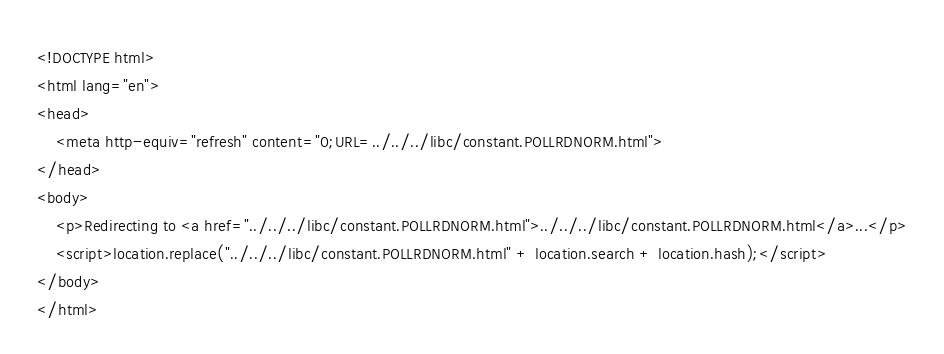<code> <loc_0><loc_0><loc_500><loc_500><_HTML_><!DOCTYPE html>
<html lang="en">
<head>
    <meta http-equiv="refresh" content="0;URL=../../../libc/constant.POLLRDNORM.html">
</head>
<body>
    <p>Redirecting to <a href="../../../libc/constant.POLLRDNORM.html">../../../libc/constant.POLLRDNORM.html</a>...</p>
    <script>location.replace("../../../libc/constant.POLLRDNORM.html" + location.search + location.hash);</script>
</body>
</html></code> 